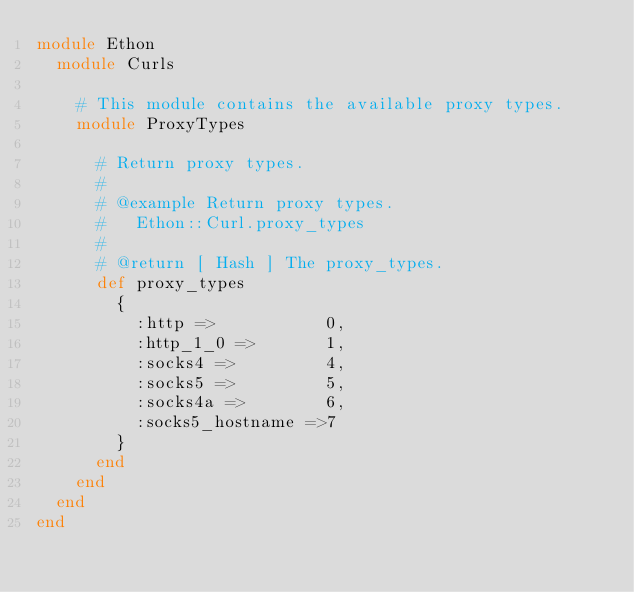<code> <loc_0><loc_0><loc_500><loc_500><_Ruby_>module Ethon
  module Curls

    # This module contains the available proxy types.
    module ProxyTypes

      # Return proxy types.
      #
      # @example Return proxy types.
      #   Ethon::Curl.proxy_types
      #
      # @return [ Hash ] The proxy_types.
      def proxy_types
        {
          :http =>           0,
          :http_1_0 =>       1,
          :socks4 =>         4,
          :socks5 =>         5,
          :socks4a =>        6,
          :socks5_hostname =>7
        }
      end
    end
  end
end
</code> 